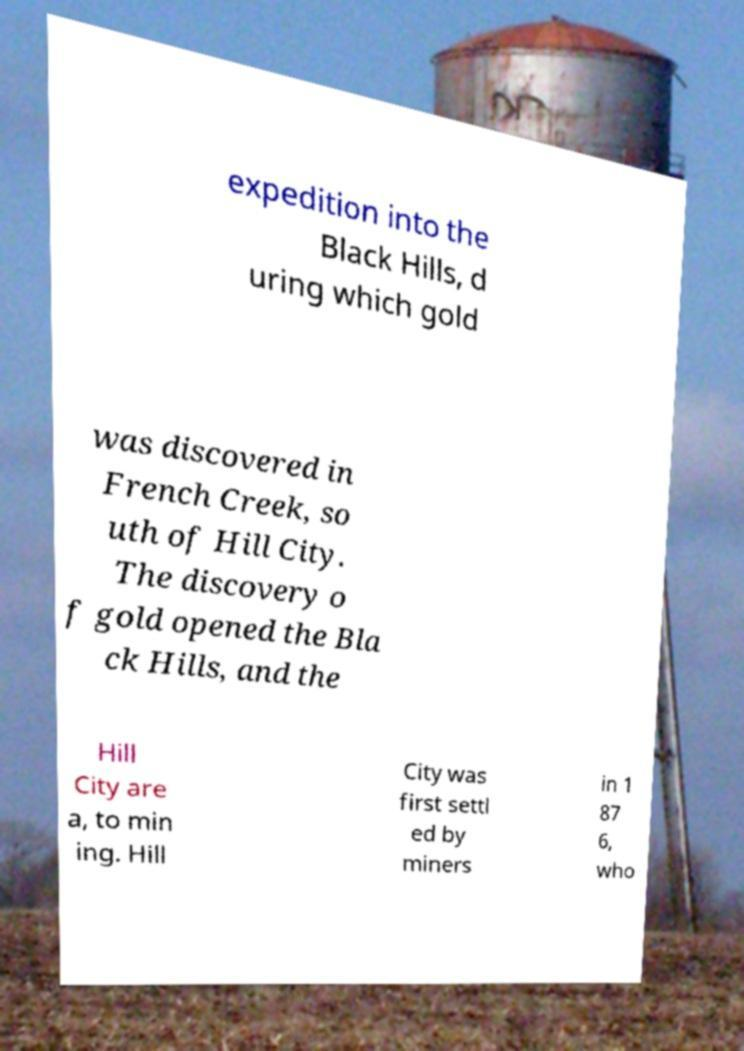I need the written content from this picture converted into text. Can you do that? expedition into the Black Hills, d uring which gold was discovered in French Creek, so uth of Hill City. The discovery o f gold opened the Bla ck Hills, and the Hill City are a, to min ing. Hill City was first settl ed by miners in 1 87 6, who 